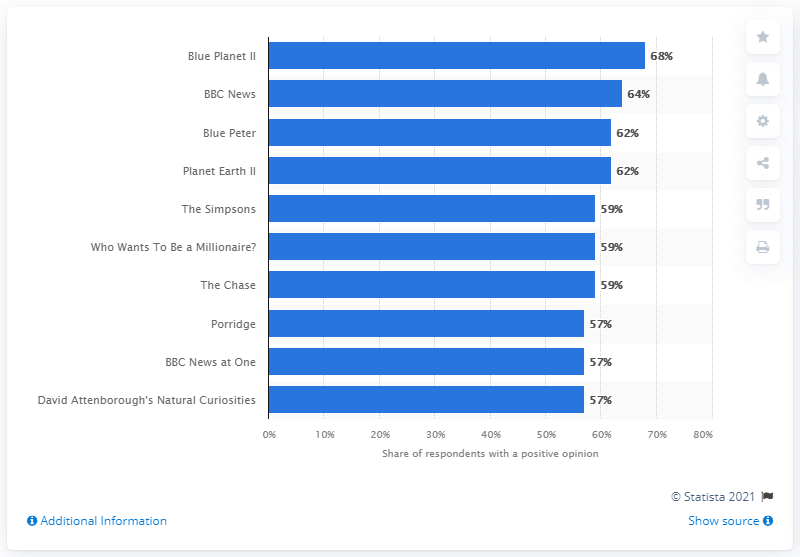What are the viewer ratings for 'The Simpsons' shown in this graph? The graph shows that 'The Simpsons' had a 59% share of respondents with a positive opinion in 2021. 